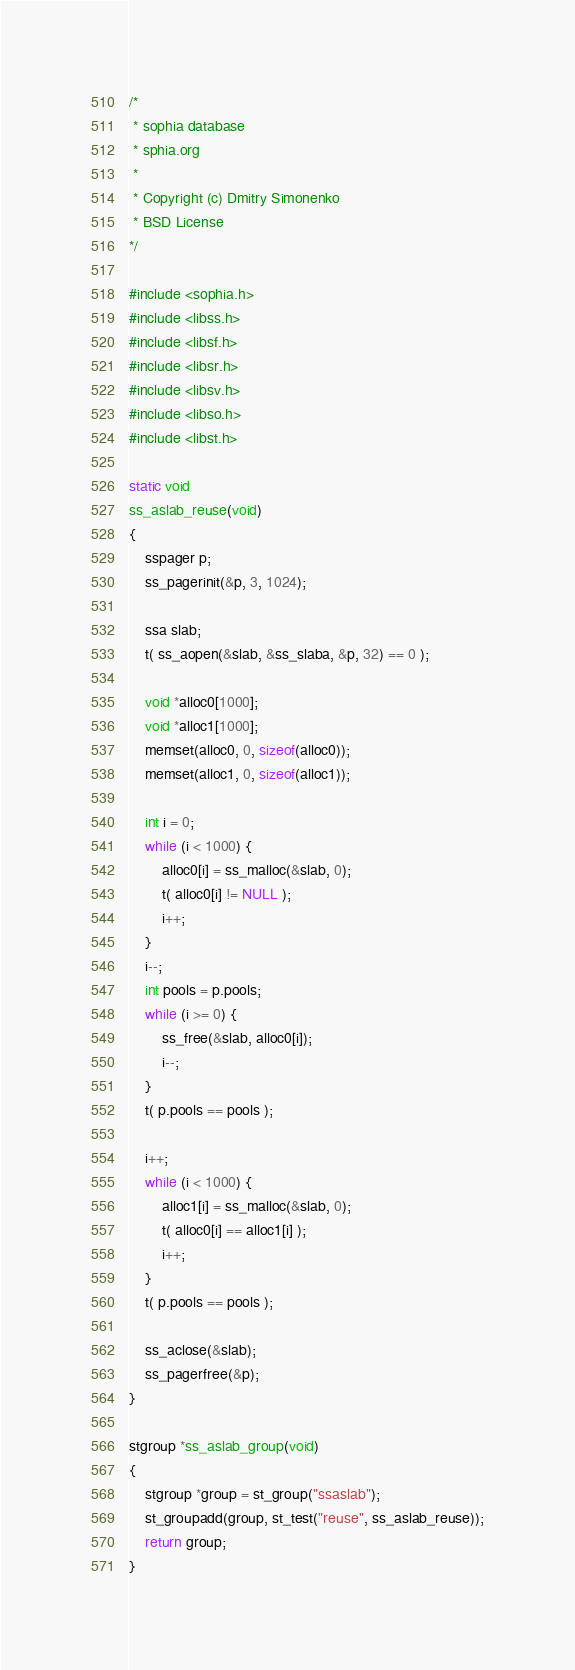<code> <loc_0><loc_0><loc_500><loc_500><_C_>
/*
 * sophia database
 * sphia.org
 *
 * Copyright (c) Dmitry Simonenko
 * BSD License
*/

#include <sophia.h>
#include <libss.h>
#include <libsf.h>
#include <libsr.h>
#include <libsv.h>
#include <libso.h>
#include <libst.h>

static void
ss_aslab_reuse(void)
{
	sspager p;
	ss_pagerinit(&p, 3, 1024);

	ssa slab;
	t( ss_aopen(&slab, &ss_slaba, &p, 32) == 0 );

	void *alloc0[1000];
	void *alloc1[1000];
	memset(alloc0, 0, sizeof(alloc0));
	memset(alloc1, 0, sizeof(alloc1));

	int i = 0;
	while (i < 1000) {
		alloc0[i] = ss_malloc(&slab, 0);
		t( alloc0[i] != NULL );
		i++;
	}
	i--;
	int pools = p.pools;
	while (i >= 0) {
		ss_free(&slab, alloc0[i]);
		i--;
	}
	t( p.pools == pools );

	i++;
	while (i < 1000) {
		alloc1[i] = ss_malloc(&slab, 0);
		t( alloc0[i] == alloc1[i] );
		i++;
	}
	t( p.pools == pools );

	ss_aclose(&slab);
	ss_pagerfree(&p);
}

stgroup *ss_aslab_group(void)
{
	stgroup *group = st_group("ssaslab");
	st_groupadd(group, st_test("reuse", ss_aslab_reuse));
	return group;
}
</code> 